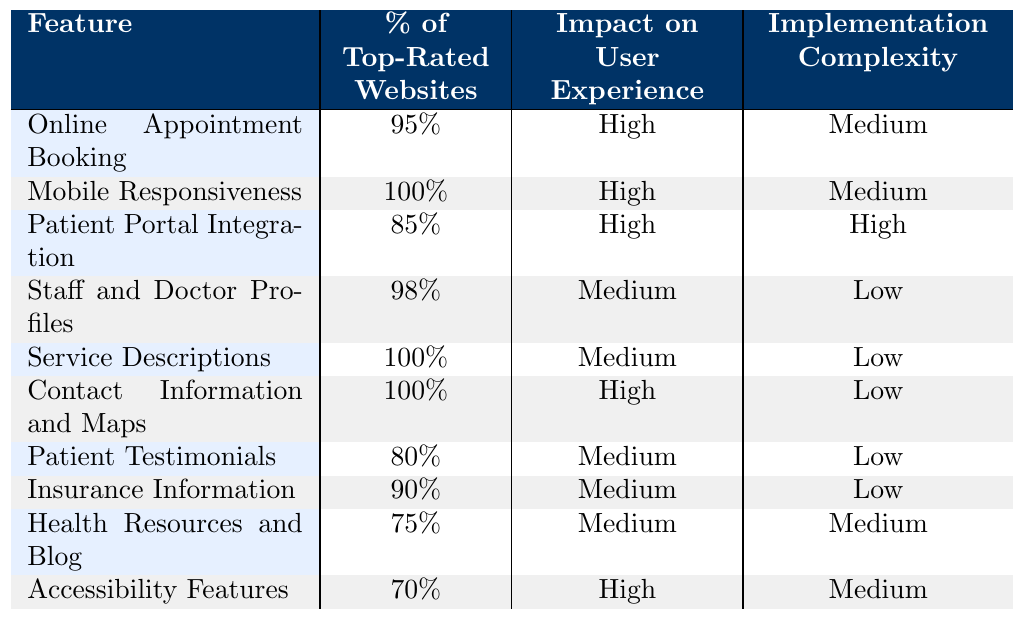What percentage of top-rated medical clinic websites feature online appointment booking? The table shows that 95% of top-rated websites include online appointment booking as a feature.
Answer: 95% Which feature has the highest implementation complexity? Patient Portal Integration is noted as having a high implementation complexity according to the table.
Answer: Patient Portal Integration How many features have a high impact on user experience? By reviewing the table, four features are identified as having a high impact on user experience: Mobile Responsiveness, Online Appointment Booking, Contact Information and Maps, and Accessibility Features.
Answer: 4 What is the average percentage of top-rated websites that include mobile responsiveness and service descriptions? Mobile Responsiveness is at 100%, and Service Descriptions is also at 100%. So, the average is (100 + 100)/2 = 100.
Answer: 100% Which feature has the lowest percentage of inclusion among top-rated websites? Health Resources and Blog has the lowest percentage with 75% as indicated in the table.
Answer: 75% Is it true that all top-rated websites provide contact information and maps? Yes, the table indicates that 100% of the top-rated websites include Contact Information and Maps.
Answer: Yes What is the difference in percentage between the feature with the highest inclusion and the feature with the lowest inclusion? The feature with the highest inclusion is Mobile Responsiveness (100%), and the feature with the lowest inclusion is Health Resources and Blog (75%). The difference is 100 - 75 = 25.
Answer: 25 How many features have a medium implementation complexity and what are they? The table lists three features with medium implementation complexity: Online Appointment Booking, Health Resources and Blog, and Accessibility Features.
Answer: 3 features: Online Appointment Booking, Health Resources and Blog, Accessibility Features Are patient testimonials included in more top-rated websites than health resources and blog? Yes, Patient Testimonials are included in 80% of top-rated websites, while Health Resources and Blog are included in 75%.
Answer: Yes What is the total percentage of top-rated websites that include both patient portal integration and insurance information? Patient Portal Integration is included in 85% of websites, and Insurance Information is included in 90%. Adding these gives 85 + 90 = 175.
Answer: 175% 